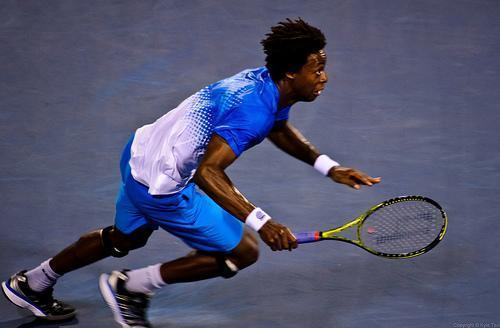How many people are there?
Give a very brief answer. 1. 